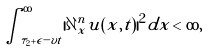<formula> <loc_0><loc_0><loc_500><loc_500>\int _ { \tau _ { 2 } + \epsilon - v t } ^ { \infty } | \partial _ { x } ^ { n } u ( x , t ) | ^ { 2 } d x < \infty ,</formula> 